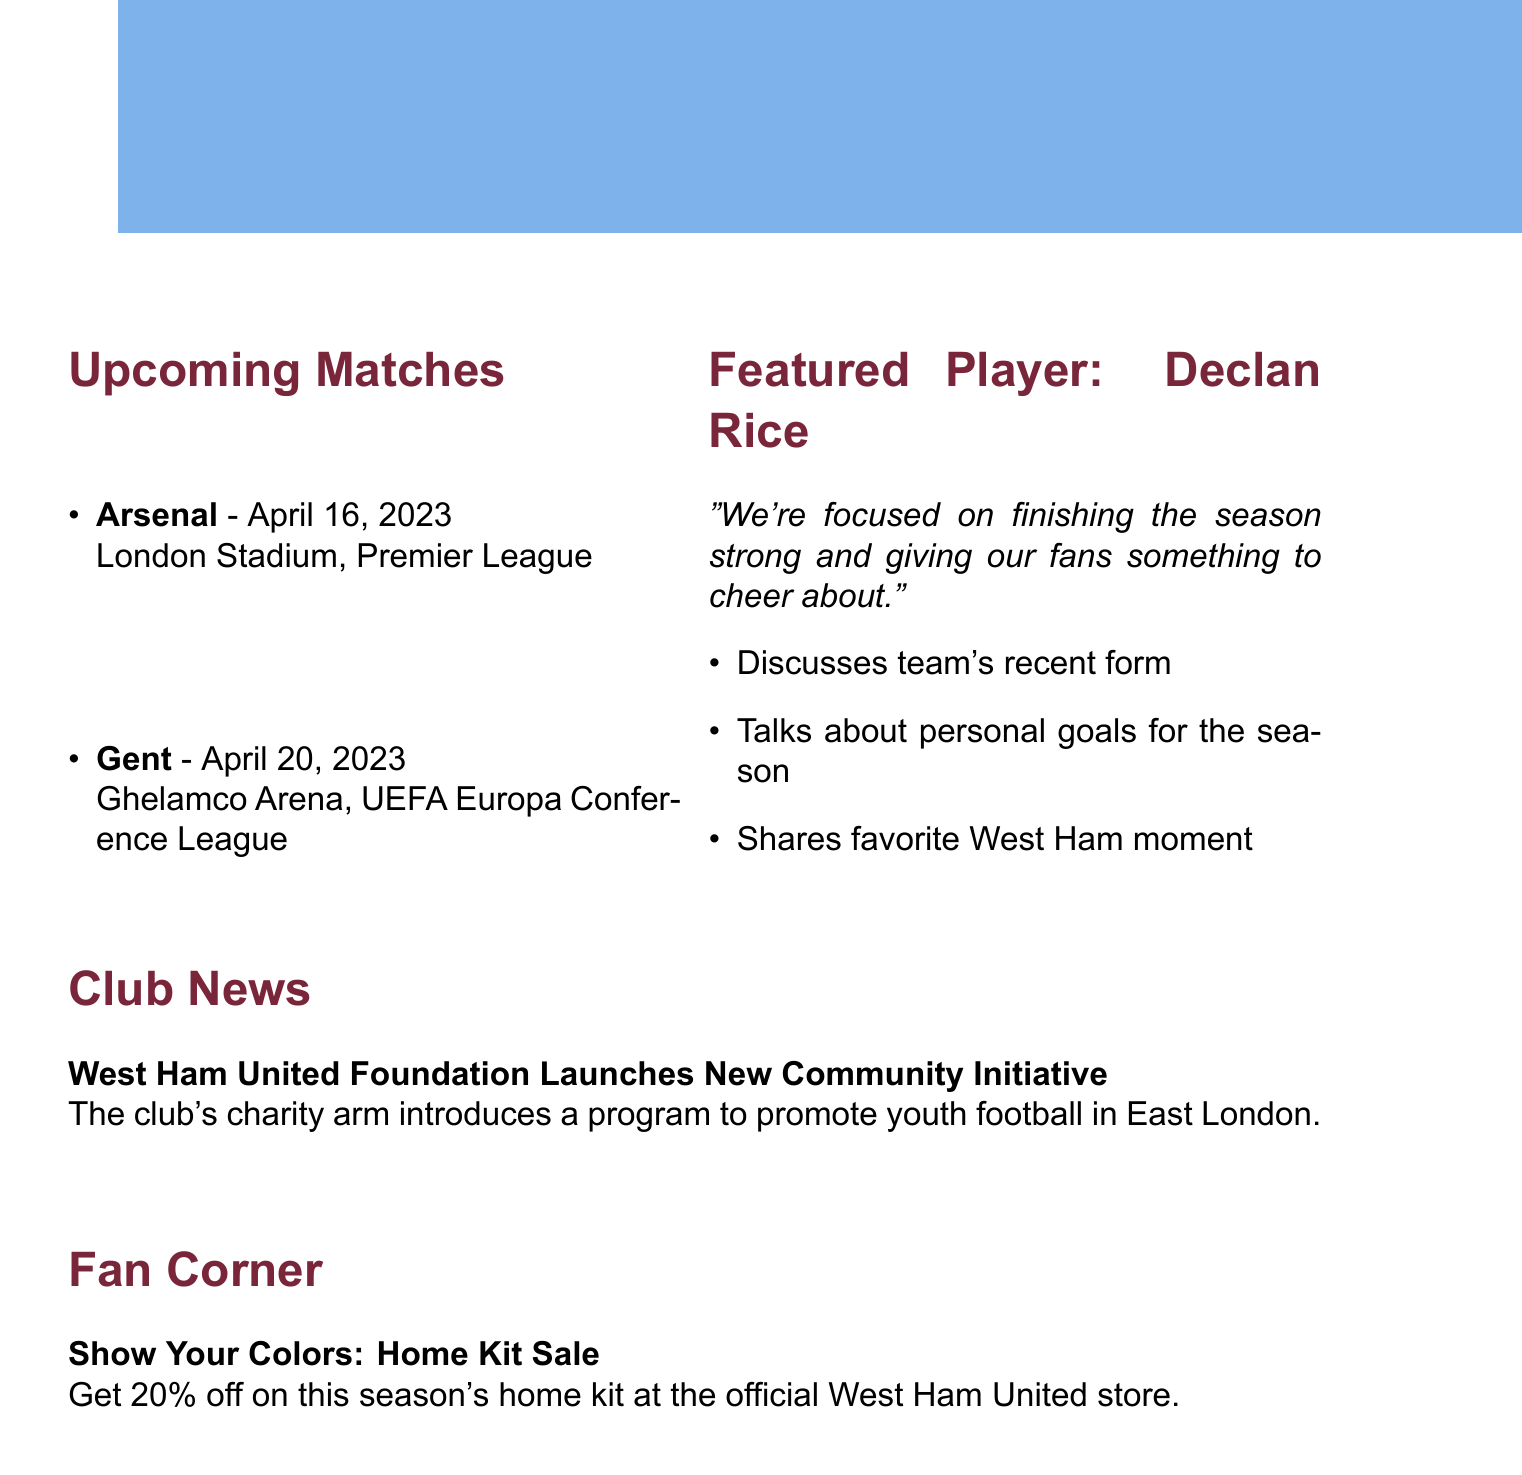What is the title of the newsletter? The title of the newsletter is provided in the document under the "newsletter_title" key.
Answer: Hammer Time: Your West Ham United Update Who is featured in the player interview? The player's name is mentioned in the "featured_player_interview" section of the document.
Answer: Declan Rice What is the date of the match against Arsenal? The date for the match is stated alongside the opponent in the "upcoming_matches" section.
Answer: April 16, 2023 What is the venue for the match against Gent? The venue for this match is provided in the "upcoming_matches" section of the document.
Answer: Ghelamco Arena What is the headline in the club news? The headline is highlighted in the "club_news" section of the document.
Answer: West Ham United Foundation Launches New Community Initiative What percentage discount is offered on the home kit? The discount percentage is specified in the "fan_corner" section of the document.
Answer: 20% What does Declan Rice focus on for the season? This focus is mentioned in the quote from the featured player interview in the document.
Answer: Finishing the season strong How many upcoming matches are listed in the newsletter? The number of matches listed can be counted from the "upcoming_matches" section.
Answer: 2 